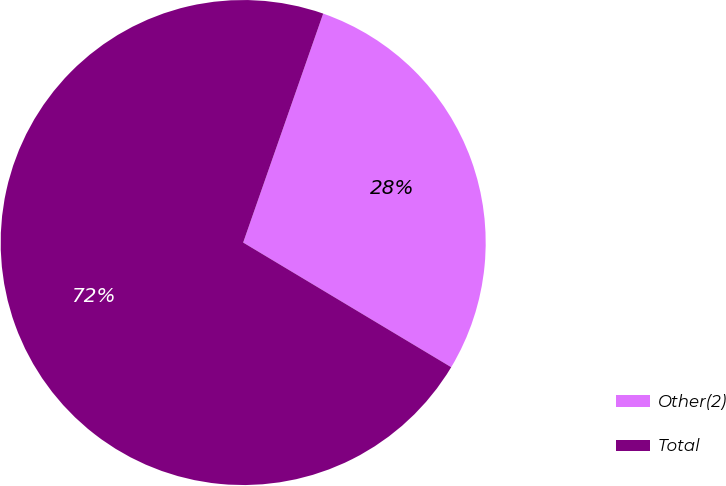<chart> <loc_0><loc_0><loc_500><loc_500><pie_chart><fcel>Other(2)<fcel>Total<nl><fcel>28.24%<fcel>71.76%<nl></chart> 